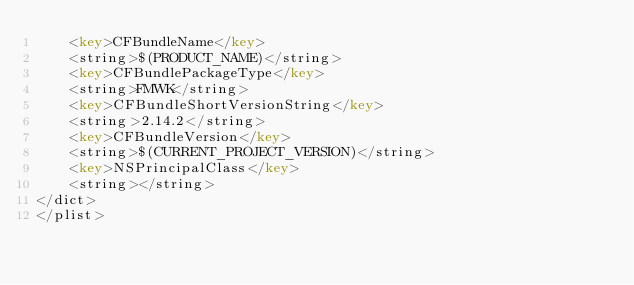<code> <loc_0><loc_0><loc_500><loc_500><_XML_>	<key>CFBundleName</key>
	<string>$(PRODUCT_NAME)</string>
	<key>CFBundlePackageType</key>
	<string>FMWK</string>
	<key>CFBundleShortVersionString</key>
	<string>2.14.2</string>
	<key>CFBundleVersion</key>
	<string>$(CURRENT_PROJECT_VERSION)</string>
	<key>NSPrincipalClass</key>
	<string></string>
</dict>
</plist>
</code> 